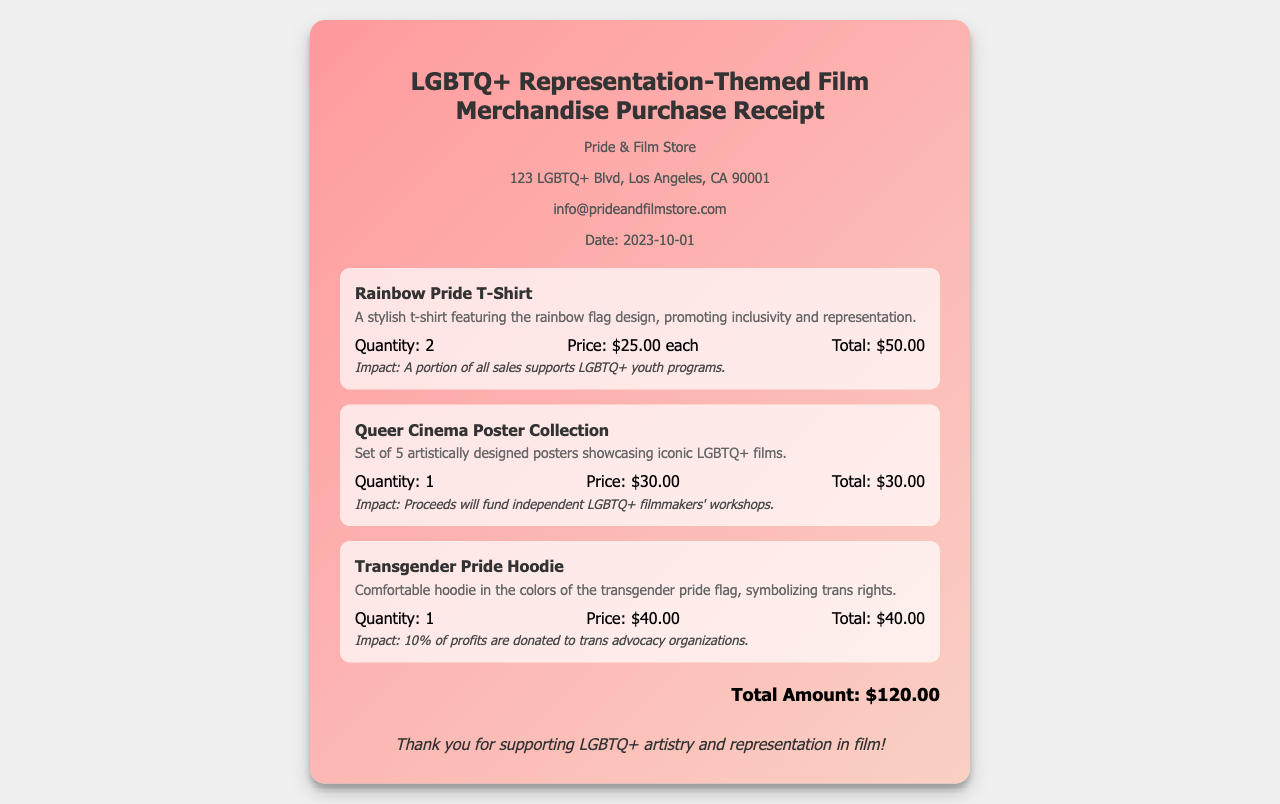What is the date of the purchase? The date of the purchase is mentioned in the document under store info.
Answer: 2023-10-01 How many Rainbow Pride T-Shirts were purchased? The quantity of Rainbow Pride T-Shirts is listed in the item details of the respective item.
Answer: 2 What is the price of the Queer Cinema Poster Collection? The price of the Queer Cinema Poster Collection is provided in the item details.
Answer: $30.00 What is the total amount spent on the merchandise? The total amount is found at the bottom of the receipt, summarizing all items purchased.
Answer: $120.00 What portion of sales supports LGBTQ+ youth programs? This information is described in the impact statement for the Rainbow Pride T-Shirt.
Answer: A portion of all sales What do the proceeds from the Queer Cinema Poster Collection fund? The impact statement describes what the proceeds fund.
Answer: Independent LGBTQ+ filmmakers' workshops What is the significance of the colors on the Transgender Pride Hoodie? The item description clarifies the symbolism of the colors in the hoodie.
Answer: Symbolizing trans rights How many posters are included in the Queer Cinema Poster Collection? The description specifies the quantity of posters included in the collection.
Answer: 5 What is expressed in the thank-you message at the end of the receipt? The thank-you message emphasizes the support for LGBTQ+ artistry and representation in film.
Answer: Support for LGBTQ+ artistry and representation in film 